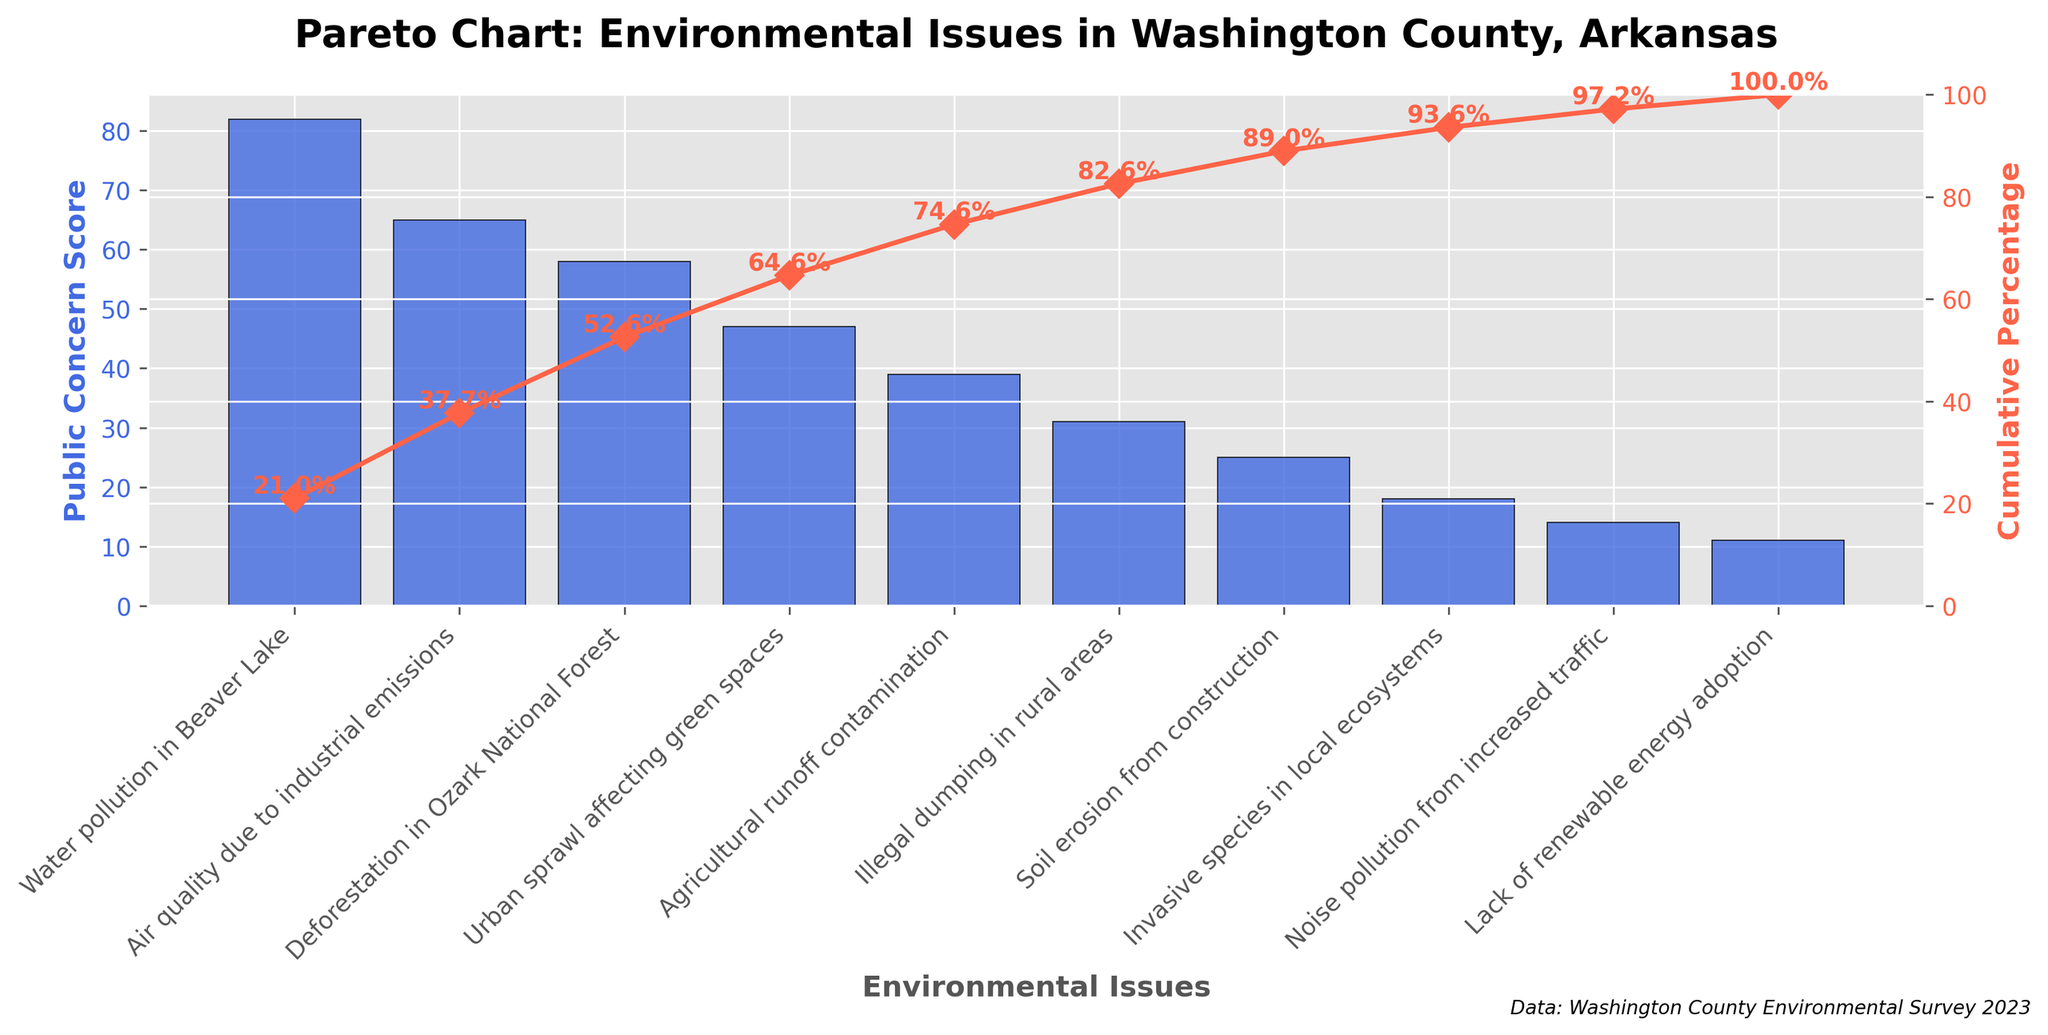What is the title of the chart? The title of the chart is written at the top and describes the main focus of the chart. Here, it reads, "Pareto Chart: Environmental Issues in Washington County, Arkansas."
Answer: Pareto Chart: Environmental Issues in Washington County, Arkansas Which environmental issue has the highest public concern score? By looking at the bar that reaches the highest value on the primary y-axis, we see that "Water pollution in Beaver Lake" has the highest score of 82.
Answer: Water pollution in Beaver Lake What is the cumulative percentage after considering the top two environmental issues? To find this, locate the cumulative percentage line and markers on the secondary y-axis. The top two issues are "Water pollution in Beaver Lake" and "Air quality due to industrial emissions," whose cumulative percentage is noted above the second bar as approximately 63.6%.
Answer: 63.6% How many environmental issues have a public concern score greater than 50? To answer this, count the number of bars whose height is above the 50 mark on the primary y-axis. The issues are "Water pollution in Beaver Lake" (82), "Air quality due to industrial emissions" (65), and "Deforestation in Ozark National Forest" (58).
Answer: 3 What environmental issue is ranked fourth in terms of public concern score? Identify the fourth tallest bar from the left and read its label, which is "Urban sprawl affecting green spaces" with a score of 47.
Answer: Urban sprawl affecting green spaces What is the total public concern score for the bottom three environmental issues? The bottom three issues are "Lack of renewable energy adoption" (11), "Noise pollution from increased traffic" (14), and "Invasive species in local ecosystems" (18). Adding these scores, we get 11 + 14 + 18 = 43.
Answer: 43 Which environmental issue contributes the least to the cumulative percentage? The smallest bar in the chart represents "Lack of renewable energy adoption," showing the lowest public concern score of 11.
Answer: Lack of renewable energy adoption How does the public concern for illegal dumping in rural areas compare with agricultural runoff contamination? Compare the heights of the bars labeled "Illegal dumping in rural areas" (31) and "Agricultural runoff contamination" (39). The score for illegal dumping is lower.
Answer: Illegal dumping in rural areas is less concerning than agricultural runoff contamination What is the cumulative percentage for the top five issues? Follow the cumulative percentage line above the fifth bar. The top five issues are "Water pollution in Beaver Lake," "Air quality due to industrial emissions," "Deforestation in Ozark National Forest," "Urban sprawl affecting green spaces," and "Agricultural runoff contamination." The cumulative percentage indicated above the fifth bar is about 83.9%.
Answer: 83.9% What is the difference in public concern score between deforestation in Ozark National Forest and urban sprawl affecting green spaces? Subtract the public concern score for "Urban sprawl affecting green spaces" (47) from "Deforestation in Ozark National Forest" (58). The difference is 58 - 47 = 11.
Answer: 11 